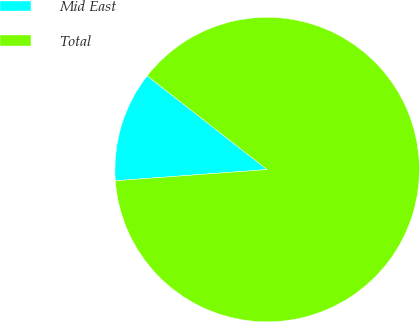Convert chart to OTSL. <chart><loc_0><loc_0><loc_500><loc_500><pie_chart><fcel>Mid East<fcel>Total<nl><fcel>11.73%<fcel>88.27%<nl></chart> 